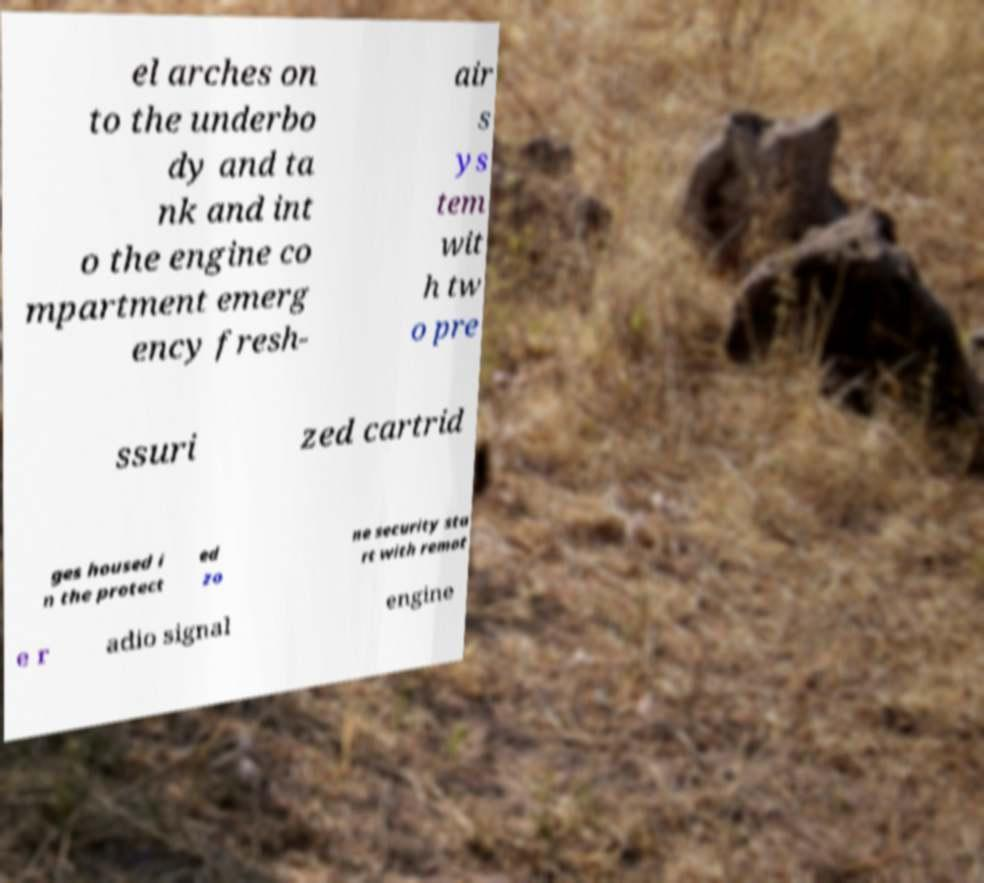Please read and relay the text visible in this image. What does it say? el arches on to the underbo dy and ta nk and int o the engine co mpartment emerg ency fresh- air s ys tem wit h tw o pre ssuri zed cartrid ges housed i n the protect ed zo ne security sta rt with remot e r adio signal engine 